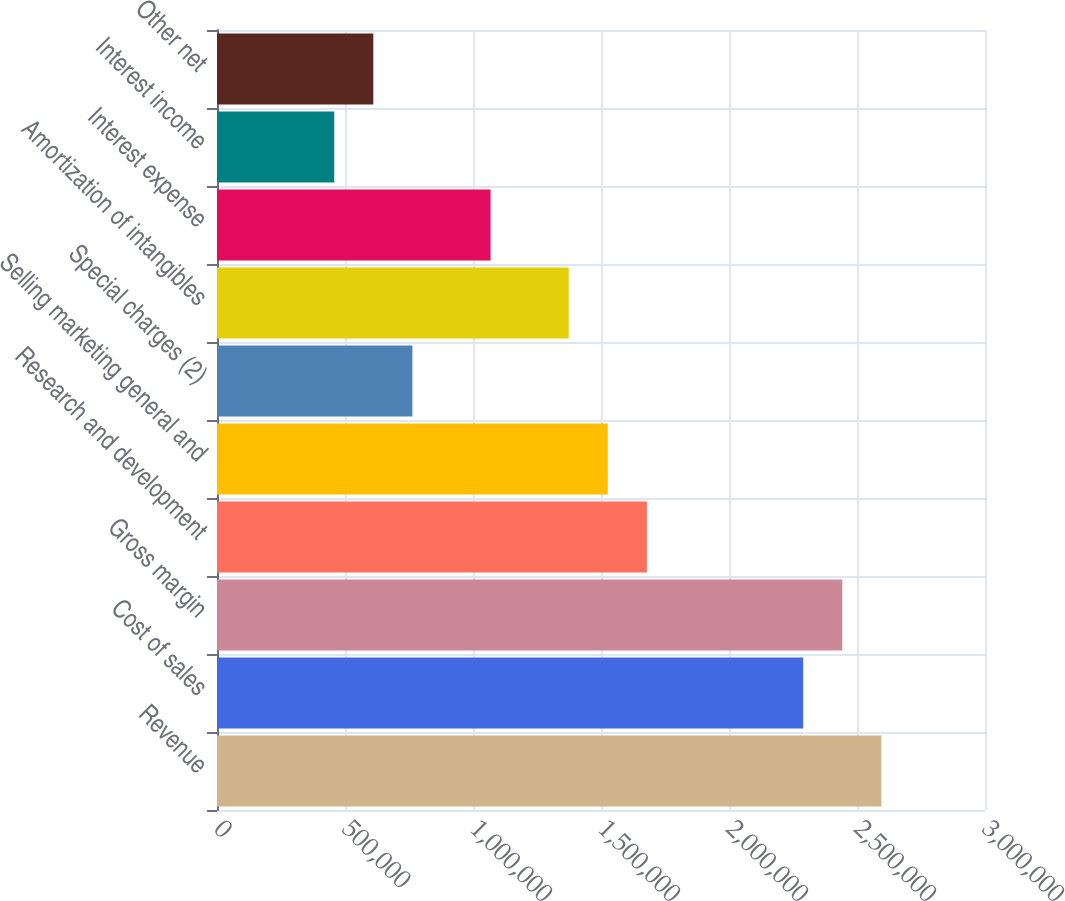Convert chart to OTSL. <chart><loc_0><loc_0><loc_500><loc_500><bar_chart><fcel>Revenue<fcel>Cost of sales<fcel>Gross margin<fcel>Research and development<fcel>Selling marketing general and<fcel>Special charges (2)<fcel>Amortization of intangibles<fcel>Interest expense<fcel>Interest income<fcel>Other net<nl><fcel>2.59522e+06<fcel>2.2899e+06<fcel>2.44256e+06<fcel>1.67926e+06<fcel>1.5266e+06<fcel>763301<fcel>1.37394e+06<fcel>1.06862e+06<fcel>457981<fcel>610641<nl></chart> 